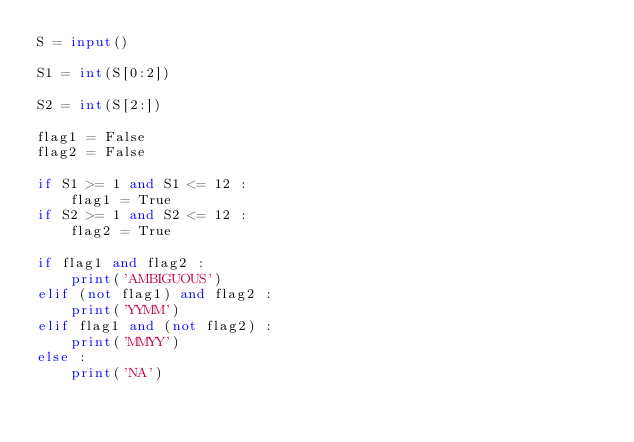<code> <loc_0><loc_0><loc_500><loc_500><_Python_>S = input()

S1 = int(S[0:2])

S2 = int(S[2:])

flag1 = False
flag2 = False

if S1 >= 1 and S1 <= 12 :
    flag1 = True
if S2 >= 1 and S2 <= 12 :
    flag2 = True

if flag1 and flag2 :
    print('AMBIGUOUS')
elif (not flag1) and flag2 :
    print('YYMM')
elif flag1 and (not flag2) :
    print('MMYY')
else :
    print('NA')
</code> 